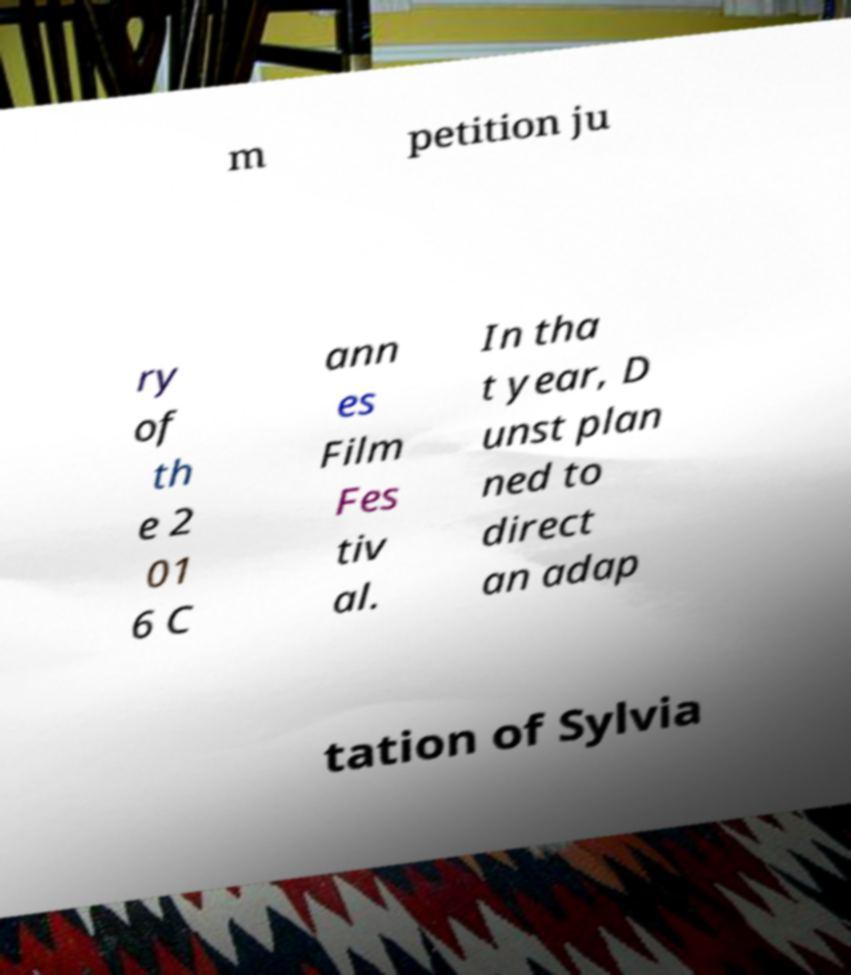For documentation purposes, I need the text within this image transcribed. Could you provide that? m petition ju ry of th e 2 01 6 C ann es Film Fes tiv al. In tha t year, D unst plan ned to direct an adap tation of Sylvia 